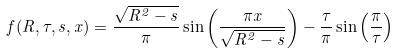<formula> <loc_0><loc_0><loc_500><loc_500>f ( R , \tau , s , x ) = \frac { \sqrt { R ^ { 2 } - s } } { \pi } \sin \left ( \frac { \pi x } { \sqrt { R ^ { 2 } - s } } \right ) - \frac { \tau } { \pi } \sin \left ( \frac { \pi } { \tau } \right )</formula> 